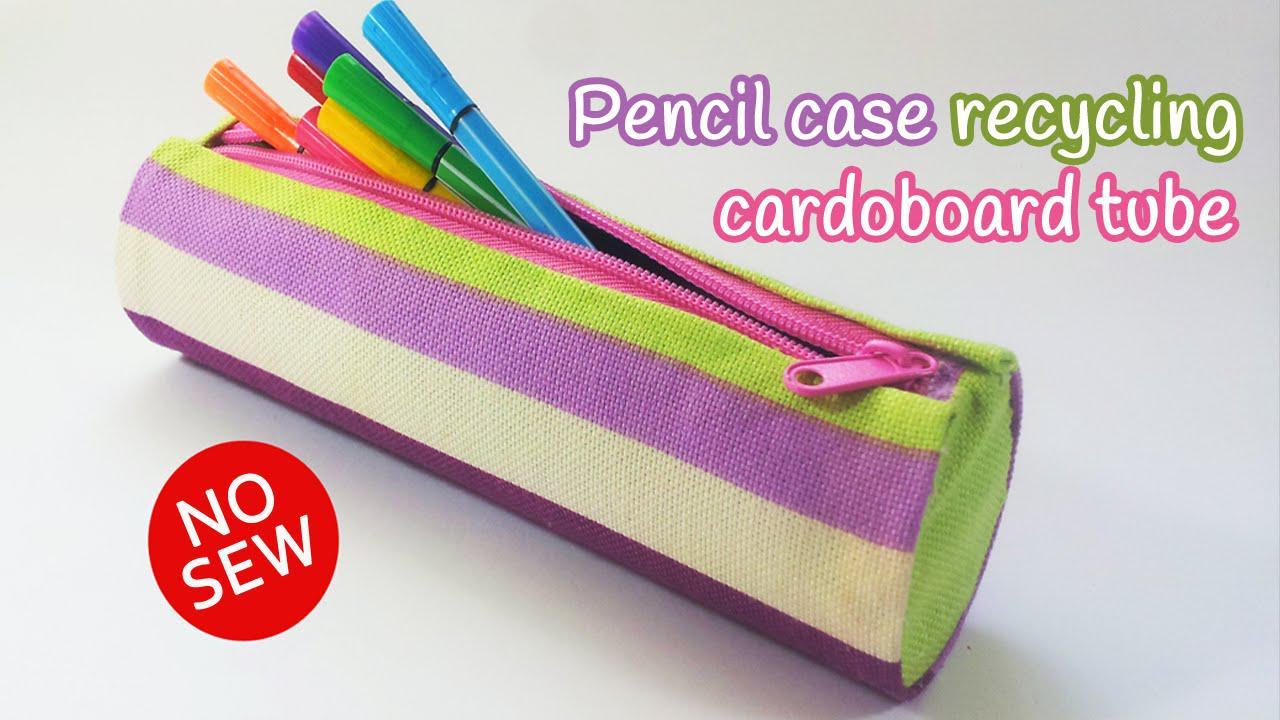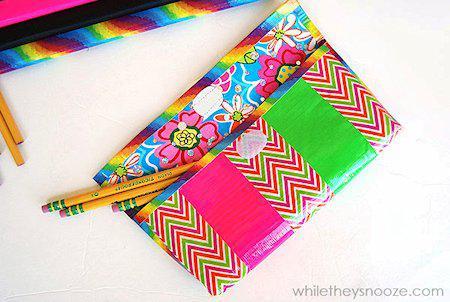The first image is the image on the left, the second image is the image on the right. Considering the images on both sides, is "An image includes a flat case with a zig-zag pattern and yellow pencils sticking out of its front pocket." valid? Answer yes or no. Yes. 